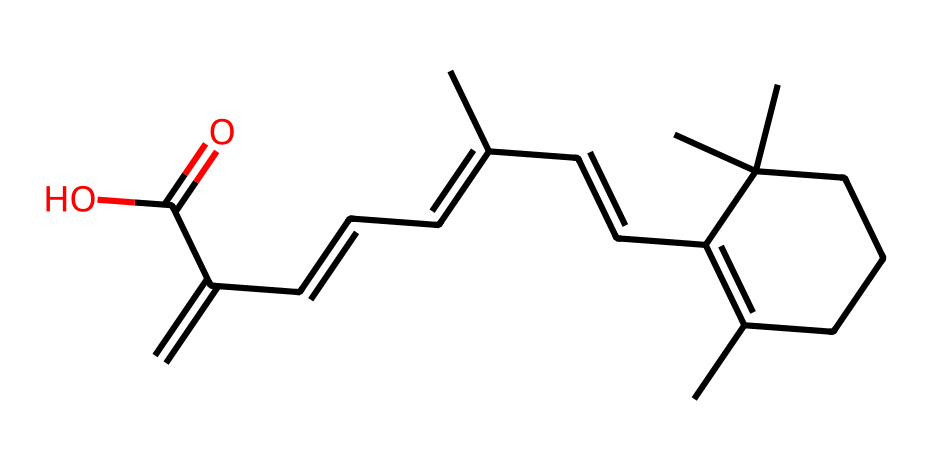how many carbon atoms are in the structure? By analyzing the SMILES representation, each 'C' corresponds to a carbon atom. Counting each carbon from the structure yields a total of 20 carbon atoms.
Answer: 20 what functional group is present in the chemical? The structural formula shows a carboxylic acid group, indicated by the 'C(=O)O' part of the SMILES representation, which represents the presence of the -COOH functional group.
Answer: carboxylic acid how many double bonds are in the structure? The structure contains multiple double bonds; each '=' sign in the SMILES notation indicates a double bond. By counting these, the representation shows a total of 6 double bonds.
Answer: 6 what is the molecular formula of this chemical? By interpreting the SMILES representation, I can derive the molecular formula by counting the corresponding atoms. The total counts are C20, H30, and O2, leading to the complete molecular formula C20H30O2.
Answer: C20H30O2 what type of skin benefit does retinol provide? Retinol is commonly recognized for its ability to stimulate collagen production and promote skin renewal, which helps in reducing wrinkles and fine lines.
Answer: anti-aging how does the presence of the carboxylic acid group affect the solubility of retinol? The carboxylic acid group increases the polarity of the molecule, which enhances its ability to interact with polar solvents, thereby making retinol more soluble in water compared to non-polar compounds.
Answer: increases solubility what role does retinol play in skin care products? Retinol acts mainly as a retinoid that promotes cell turnover and improves skin texture, making it effective for treating skin issues such as acne and aging.
Answer: promotes cell turnover 